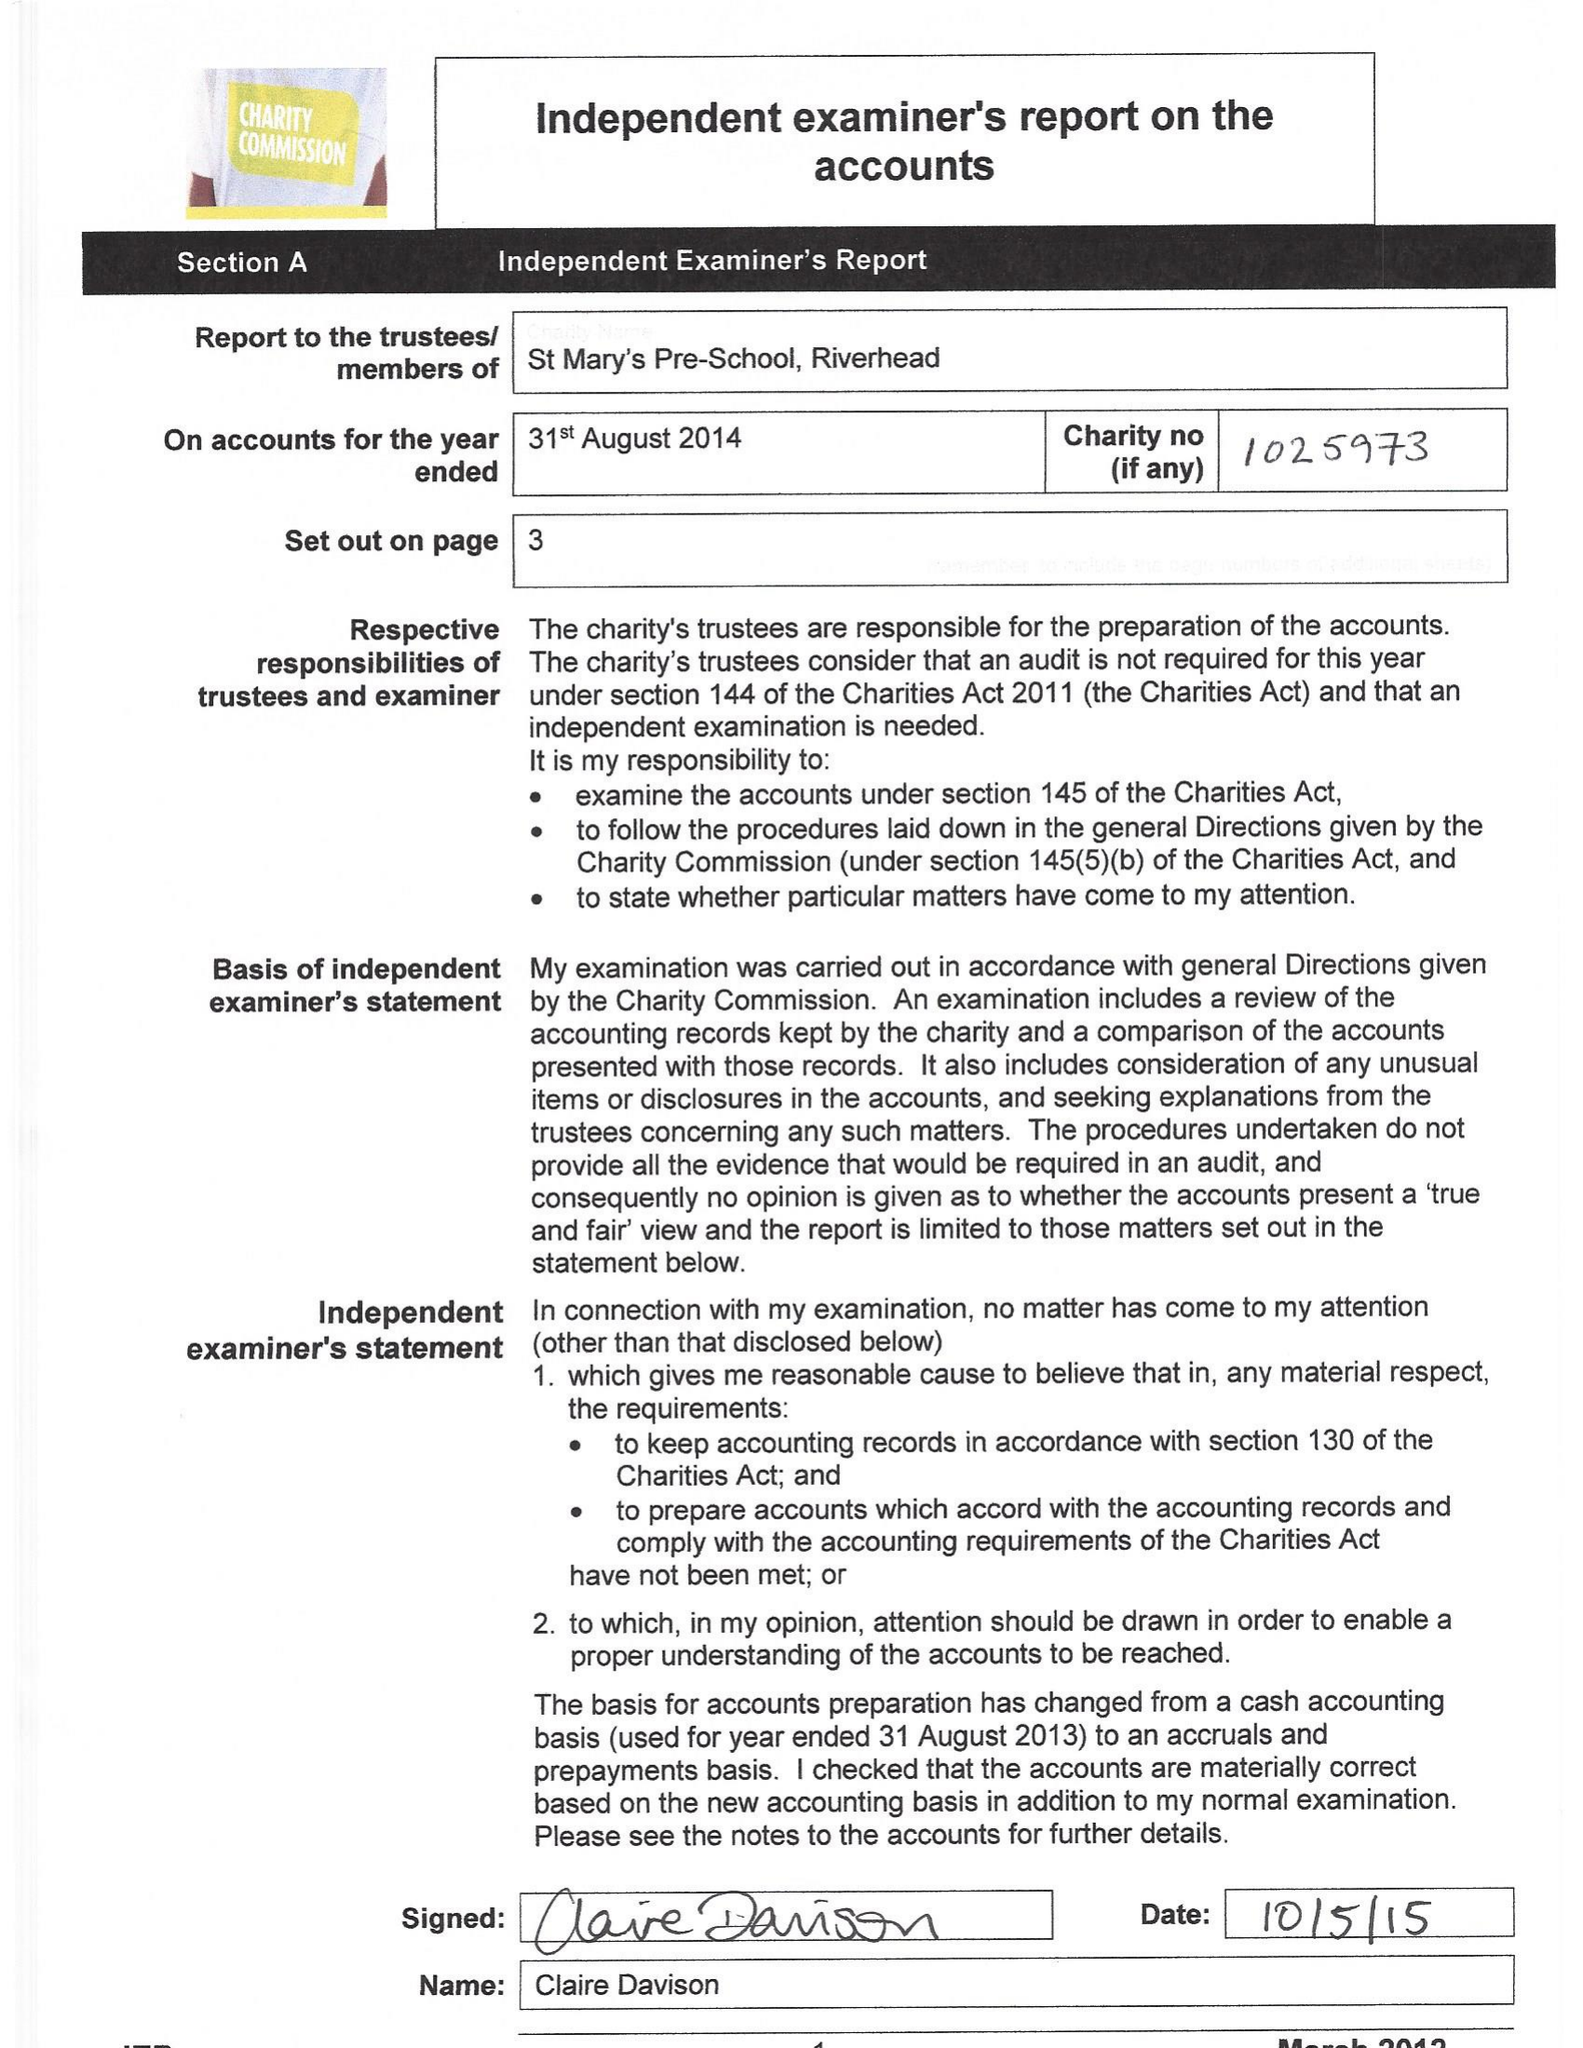What is the value for the charity_number?
Answer the question using a single word or phrase. 1025973 